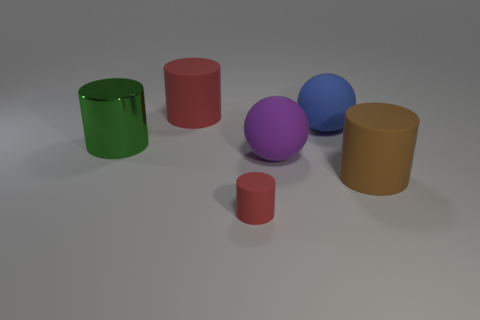Is there any other thing that has the same material as the large green thing?
Your response must be concise. No. Do the green object and the red matte thing right of the big red cylinder have the same shape?
Your answer should be very brief. Yes. What is the shape of the red object that is on the left side of the red cylinder to the right of the red cylinder behind the large green object?
Provide a short and direct response. Cylinder. How many other objects are the same material as the purple thing?
Ensure brevity in your answer.  4. What number of objects are either matte objects that are to the right of the large purple rubber ball or metal cylinders?
Keep it short and to the point. 3. The red matte thing in front of the red object that is to the left of the tiny matte cylinder is what shape?
Your answer should be compact. Cylinder. There is a red object in front of the large green shiny thing; is it the same shape as the big brown matte object?
Your answer should be very brief. Yes. What is the color of the cylinder that is to the right of the tiny red rubber cylinder?
Offer a terse response. Brown. How many cylinders are either purple things or blue rubber objects?
Make the answer very short. 0. How big is the red object that is in front of the sphere in front of the big green metal object?
Your response must be concise. Small. 